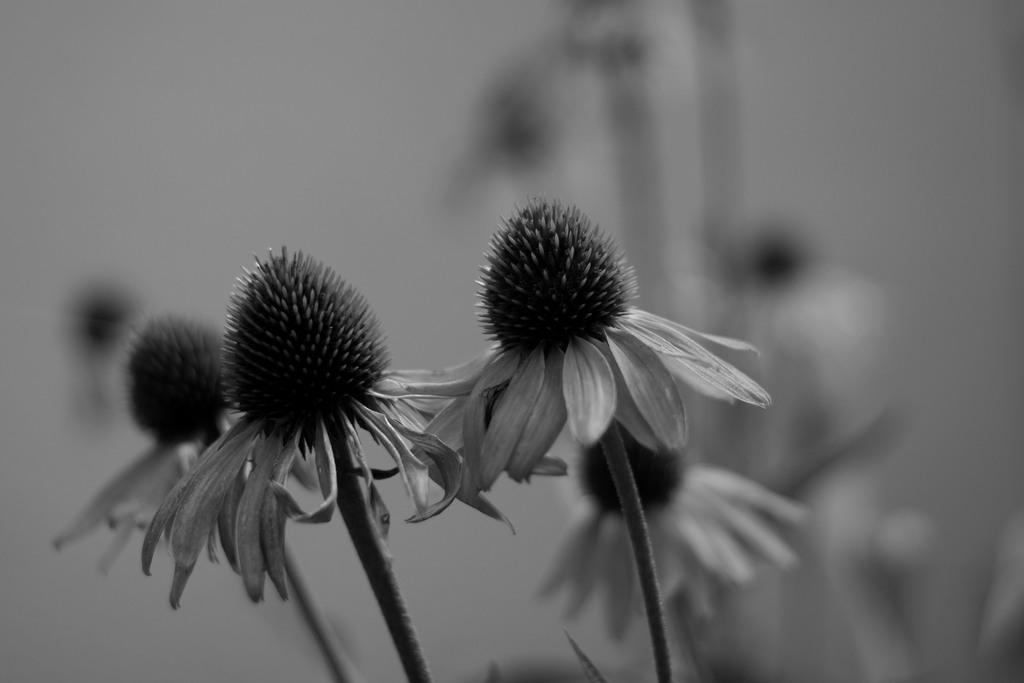What type of image is present in the picture? There is a black and white photograph in the image. What is depicted in the photograph? The photograph contains flowers. What part of the flowers can be seen in the photograph? The flowers have stems. Are there any other flowers visible in the image? Yes, there are other flowers visible behind the photograph, but they are not clearly visible. Reasoning: Let's think step by step a specific detail about the image that is known from the provided facts. We start by identifying the main subject in the image, which is the black and white photograph. Then, we expand the conversation to include the content of the photograph, focusing on the flowers and their stems. Finally, we mention the presence of other flowers in the image, acknowledging that they are not clearly visible. Absurd Question/Answer: What type of star can be seen guiding the flowers in the image? There is no star or guiding element present in the image; it features a black and white photograph of flowers with stems. 